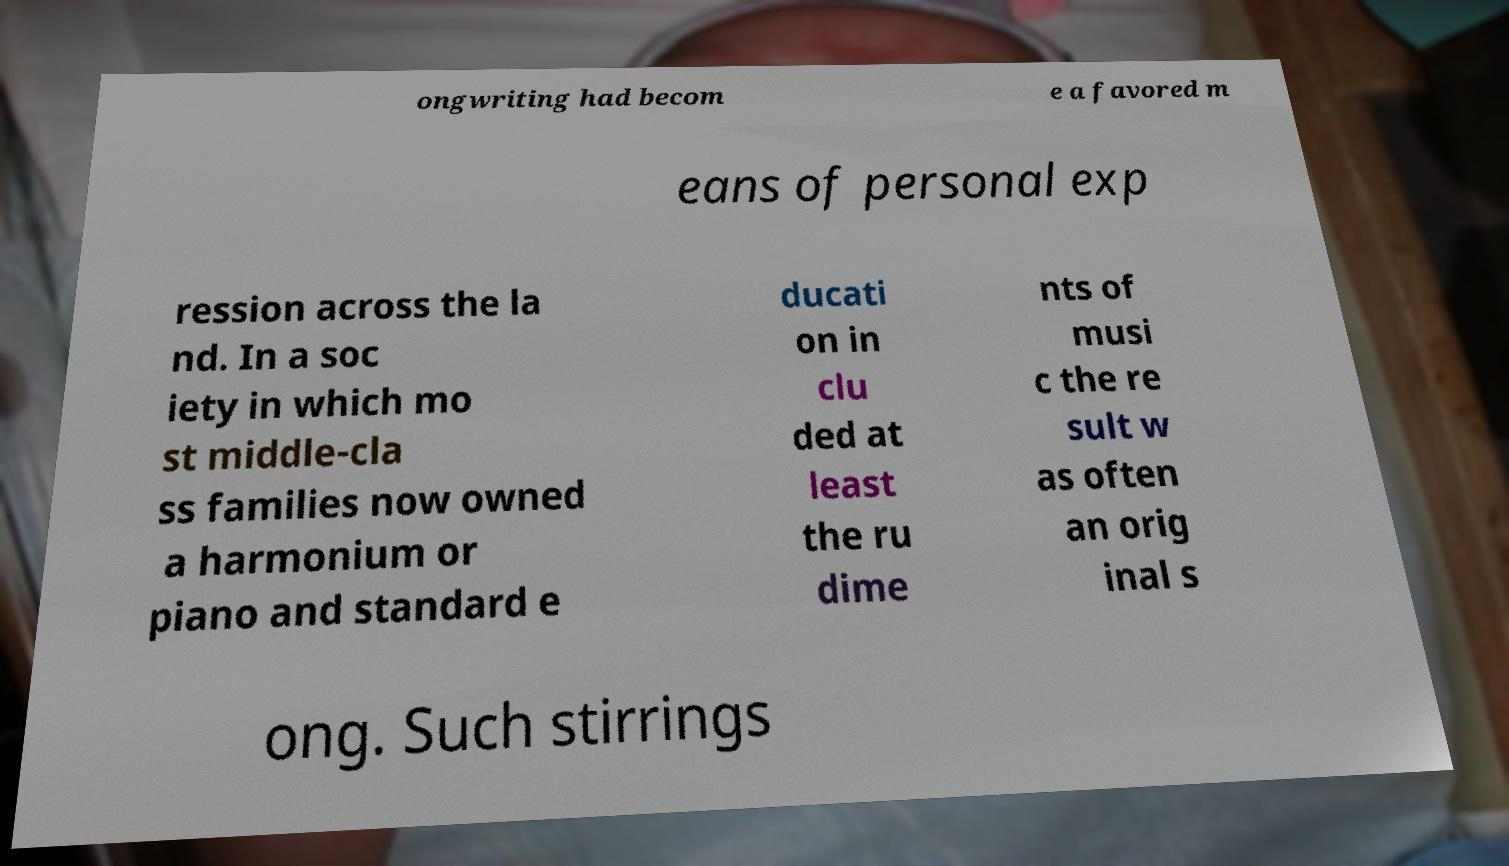Please read and relay the text visible in this image. What does it say? ongwriting had becom e a favored m eans of personal exp ression across the la nd. In a soc iety in which mo st middle-cla ss families now owned a harmonium or piano and standard e ducati on in clu ded at least the ru dime nts of musi c the re sult w as often an orig inal s ong. Such stirrings 